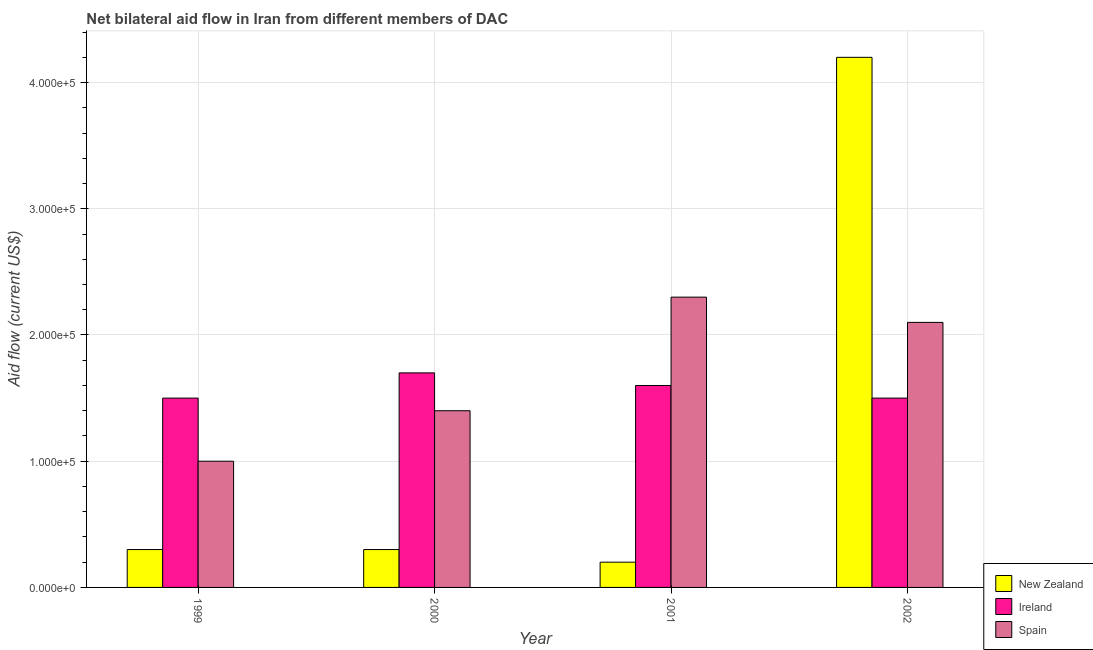How many groups of bars are there?
Offer a terse response. 4. Are the number of bars per tick equal to the number of legend labels?
Offer a very short reply. Yes. Are the number of bars on each tick of the X-axis equal?
Your answer should be very brief. Yes. How many bars are there on the 3rd tick from the left?
Your response must be concise. 3. What is the label of the 4th group of bars from the left?
Provide a succinct answer. 2002. In how many cases, is the number of bars for a given year not equal to the number of legend labels?
Your answer should be compact. 0. What is the amount of aid provided by new zealand in 2000?
Offer a very short reply. 3.00e+04. Across all years, what is the maximum amount of aid provided by ireland?
Your response must be concise. 1.70e+05. Across all years, what is the minimum amount of aid provided by new zealand?
Give a very brief answer. 2.00e+04. What is the total amount of aid provided by spain in the graph?
Offer a very short reply. 6.80e+05. What is the difference between the amount of aid provided by ireland in 1999 and that in 2001?
Your response must be concise. -10000. What is the difference between the amount of aid provided by spain in 1999 and the amount of aid provided by ireland in 2000?
Keep it short and to the point. -4.00e+04. What is the average amount of aid provided by ireland per year?
Offer a terse response. 1.58e+05. In how many years, is the amount of aid provided by new zealand greater than 320000 US$?
Your answer should be very brief. 1. What is the ratio of the amount of aid provided by ireland in 2001 to that in 2002?
Provide a short and direct response. 1.07. What is the difference between the highest and the lowest amount of aid provided by new zealand?
Offer a very short reply. 4.00e+05. Is the sum of the amount of aid provided by ireland in 2001 and 2002 greater than the maximum amount of aid provided by spain across all years?
Offer a very short reply. Yes. What does the 2nd bar from the left in 2001 represents?
Offer a terse response. Ireland. What does the 3rd bar from the right in 1999 represents?
Ensure brevity in your answer.  New Zealand. Are all the bars in the graph horizontal?
Give a very brief answer. No. What is the difference between two consecutive major ticks on the Y-axis?
Keep it short and to the point. 1.00e+05. Are the values on the major ticks of Y-axis written in scientific E-notation?
Your answer should be compact. Yes. Does the graph contain any zero values?
Ensure brevity in your answer.  No. Does the graph contain grids?
Offer a terse response. Yes. Where does the legend appear in the graph?
Your answer should be very brief. Bottom right. How are the legend labels stacked?
Make the answer very short. Vertical. What is the title of the graph?
Offer a terse response. Net bilateral aid flow in Iran from different members of DAC. What is the label or title of the X-axis?
Your answer should be very brief. Year. What is the label or title of the Y-axis?
Provide a short and direct response. Aid flow (current US$). What is the Aid flow (current US$) in Ireland in 1999?
Ensure brevity in your answer.  1.50e+05. What is the Aid flow (current US$) in Ireland in 2000?
Provide a succinct answer. 1.70e+05. What is the Aid flow (current US$) of Spain in 2000?
Provide a succinct answer. 1.40e+05. What is the Aid flow (current US$) of Ireland in 2001?
Your response must be concise. 1.60e+05. What is the Aid flow (current US$) of Ireland in 2002?
Your answer should be compact. 1.50e+05. Across all years, what is the maximum Aid flow (current US$) of New Zealand?
Provide a short and direct response. 4.20e+05. Across all years, what is the maximum Aid flow (current US$) in Ireland?
Your answer should be compact. 1.70e+05. Across all years, what is the maximum Aid flow (current US$) in Spain?
Your answer should be compact. 2.30e+05. Across all years, what is the minimum Aid flow (current US$) in New Zealand?
Provide a succinct answer. 2.00e+04. Across all years, what is the minimum Aid flow (current US$) in Ireland?
Offer a very short reply. 1.50e+05. What is the total Aid flow (current US$) of Ireland in the graph?
Keep it short and to the point. 6.30e+05. What is the total Aid flow (current US$) of Spain in the graph?
Your response must be concise. 6.80e+05. What is the difference between the Aid flow (current US$) of Ireland in 1999 and that in 2001?
Provide a succinct answer. -10000. What is the difference between the Aid flow (current US$) of Spain in 1999 and that in 2001?
Make the answer very short. -1.30e+05. What is the difference between the Aid flow (current US$) in New Zealand in 1999 and that in 2002?
Give a very brief answer. -3.90e+05. What is the difference between the Aid flow (current US$) of Ireland in 2000 and that in 2001?
Your response must be concise. 10000. What is the difference between the Aid flow (current US$) of Spain in 2000 and that in 2001?
Provide a short and direct response. -9.00e+04. What is the difference between the Aid flow (current US$) in New Zealand in 2000 and that in 2002?
Your answer should be compact. -3.90e+05. What is the difference between the Aid flow (current US$) of Ireland in 2000 and that in 2002?
Provide a short and direct response. 2.00e+04. What is the difference between the Aid flow (current US$) in New Zealand in 2001 and that in 2002?
Provide a succinct answer. -4.00e+05. What is the difference between the Aid flow (current US$) of Ireland in 2001 and that in 2002?
Give a very brief answer. 10000. What is the difference between the Aid flow (current US$) in Spain in 2001 and that in 2002?
Your answer should be very brief. 2.00e+04. What is the difference between the Aid flow (current US$) in New Zealand in 1999 and the Aid flow (current US$) in Ireland in 2000?
Keep it short and to the point. -1.40e+05. What is the difference between the Aid flow (current US$) in Ireland in 1999 and the Aid flow (current US$) in Spain in 2001?
Ensure brevity in your answer.  -8.00e+04. What is the difference between the Aid flow (current US$) of New Zealand in 1999 and the Aid flow (current US$) of Ireland in 2002?
Make the answer very short. -1.20e+05. What is the difference between the Aid flow (current US$) in New Zealand in 1999 and the Aid flow (current US$) in Spain in 2002?
Offer a very short reply. -1.80e+05. What is the difference between the Aid flow (current US$) in New Zealand in 2000 and the Aid flow (current US$) in Spain in 2002?
Your answer should be compact. -1.80e+05. What is the average Aid flow (current US$) in New Zealand per year?
Provide a succinct answer. 1.25e+05. What is the average Aid flow (current US$) in Ireland per year?
Provide a short and direct response. 1.58e+05. In the year 1999, what is the difference between the Aid flow (current US$) of New Zealand and Aid flow (current US$) of Ireland?
Give a very brief answer. -1.20e+05. In the year 1999, what is the difference between the Aid flow (current US$) of New Zealand and Aid flow (current US$) of Spain?
Offer a very short reply. -7.00e+04. In the year 2001, what is the difference between the Aid flow (current US$) in Ireland and Aid flow (current US$) in Spain?
Give a very brief answer. -7.00e+04. In the year 2002, what is the difference between the Aid flow (current US$) of New Zealand and Aid flow (current US$) of Ireland?
Ensure brevity in your answer.  2.70e+05. In the year 2002, what is the difference between the Aid flow (current US$) in New Zealand and Aid flow (current US$) in Spain?
Your response must be concise. 2.10e+05. What is the ratio of the Aid flow (current US$) in Ireland in 1999 to that in 2000?
Ensure brevity in your answer.  0.88. What is the ratio of the Aid flow (current US$) of Spain in 1999 to that in 2001?
Provide a succinct answer. 0.43. What is the ratio of the Aid flow (current US$) of New Zealand in 1999 to that in 2002?
Provide a succinct answer. 0.07. What is the ratio of the Aid flow (current US$) of Spain in 1999 to that in 2002?
Give a very brief answer. 0.48. What is the ratio of the Aid flow (current US$) of New Zealand in 2000 to that in 2001?
Provide a short and direct response. 1.5. What is the ratio of the Aid flow (current US$) of Ireland in 2000 to that in 2001?
Your response must be concise. 1.06. What is the ratio of the Aid flow (current US$) of Spain in 2000 to that in 2001?
Keep it short and to the point. 0.61. What is the ratio of the Aid flow (current US$) in New Zealand in 2000 to that in 2002?
Offer a terse response. 0.07. What is the ratio of the Aid flow (current US$) in Ireland in 2000 to that in 2002?
Make the answer very short. 1.13. What is the ratio of the Aid flow (current US$) in Spain in 2000 to that in 2002?
Keep it short and to the point. 0.67. What is the ratio of the Aid flow (current US$) in New Zealand in 2001 to that in 2002?
Offer a terse response. 0.05. What is the ratio of the Aid flow (current US$) in Ireland in 2001 to that in 2002?
Offer a very short reply. 1.07. What is the ratio of the Aid flow (current US$) of Spain in 2001 to that in 2002?
Offer a terse response. 1.1. What is the difference between the highest and the second highest Aid flow (current US$) in Spain?
Give a very brief answer. 2.00e+04. What is the difference between the highest and the lowest Aid flow (current US$) of New Zealand?
Offer a very short reply. 4.00e+05. What is the difference between the highest and the lowest Aid flow (current US$) in Ireland?
Give a very brief answer. 2.00e+04. What is the difference between the highest and the lowest Aid flow (current US$) of Spain?
Provide a succinct answer. 1.30e+05. 